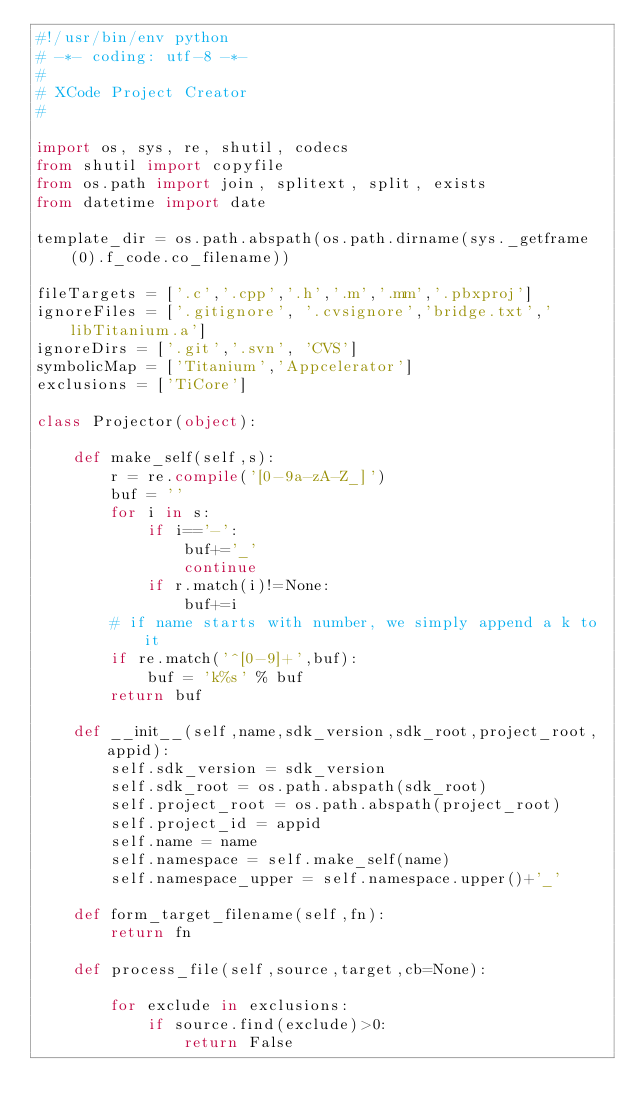<code> <loc_0><loc_0><loc_500><loc_500><_Python_>#!/usr/bin/env python
# -*- coding: utf-8 -*-
#
# XCode Project Creator
#

import os, sys, re, shutil, codecs
from shutil import copyfile
from os.path import join, splitext, split, exists
from datetime import date

template_dir = os.path.abspath(os.path.dirname(sys._getframe(0).f_code.co_filename))
	
fileTargets = ['.c','.cpp','.h','.m','.mm','.pbxproj']
ignoreFiles = ['.gitignore', '.cvsignore','bridge.txt','libTitanium.a']
ignoreDirs = ['.git','.svn', 'CVS']
symbolicMap = ['Titanium','Appcelerator']
exclusions = ['TiCore']

class Projector(object):
	
	def make_self(self,s):
		r = re.compile('[0-9a-zA-Z_]')
		buf = ''
		for i in s:
			if i=='-':
				buf+='_'
				continue
			if r.match(i)!=None:
				buf+=i
		# if name starts with number, we simply append a k to it
		if re.match('^[0-9]+',buf):
			buf = 'k%s' % buf
		return buf
		
	def __init__(self,name,sdk_version,sdk_root,project_root,appid):
		self.sdk_version = sdk_version
		self.sdk_root = os.path.abspath(sdk_root)
		self.project_root = os.path.abspath(project_root)
		self.project_id = appid
		self.name = name
		self.namespace = self.make_self(name)
		self.namespace_upper = self.namespace.upper()+'_'

	def form_target_filename(self,fn):
		return fn
				
	def process_file(self,source,target,cb=None):
	
		for exclude in exclusions:
			if source.find(exclude)>0:
				return False
				</code> 